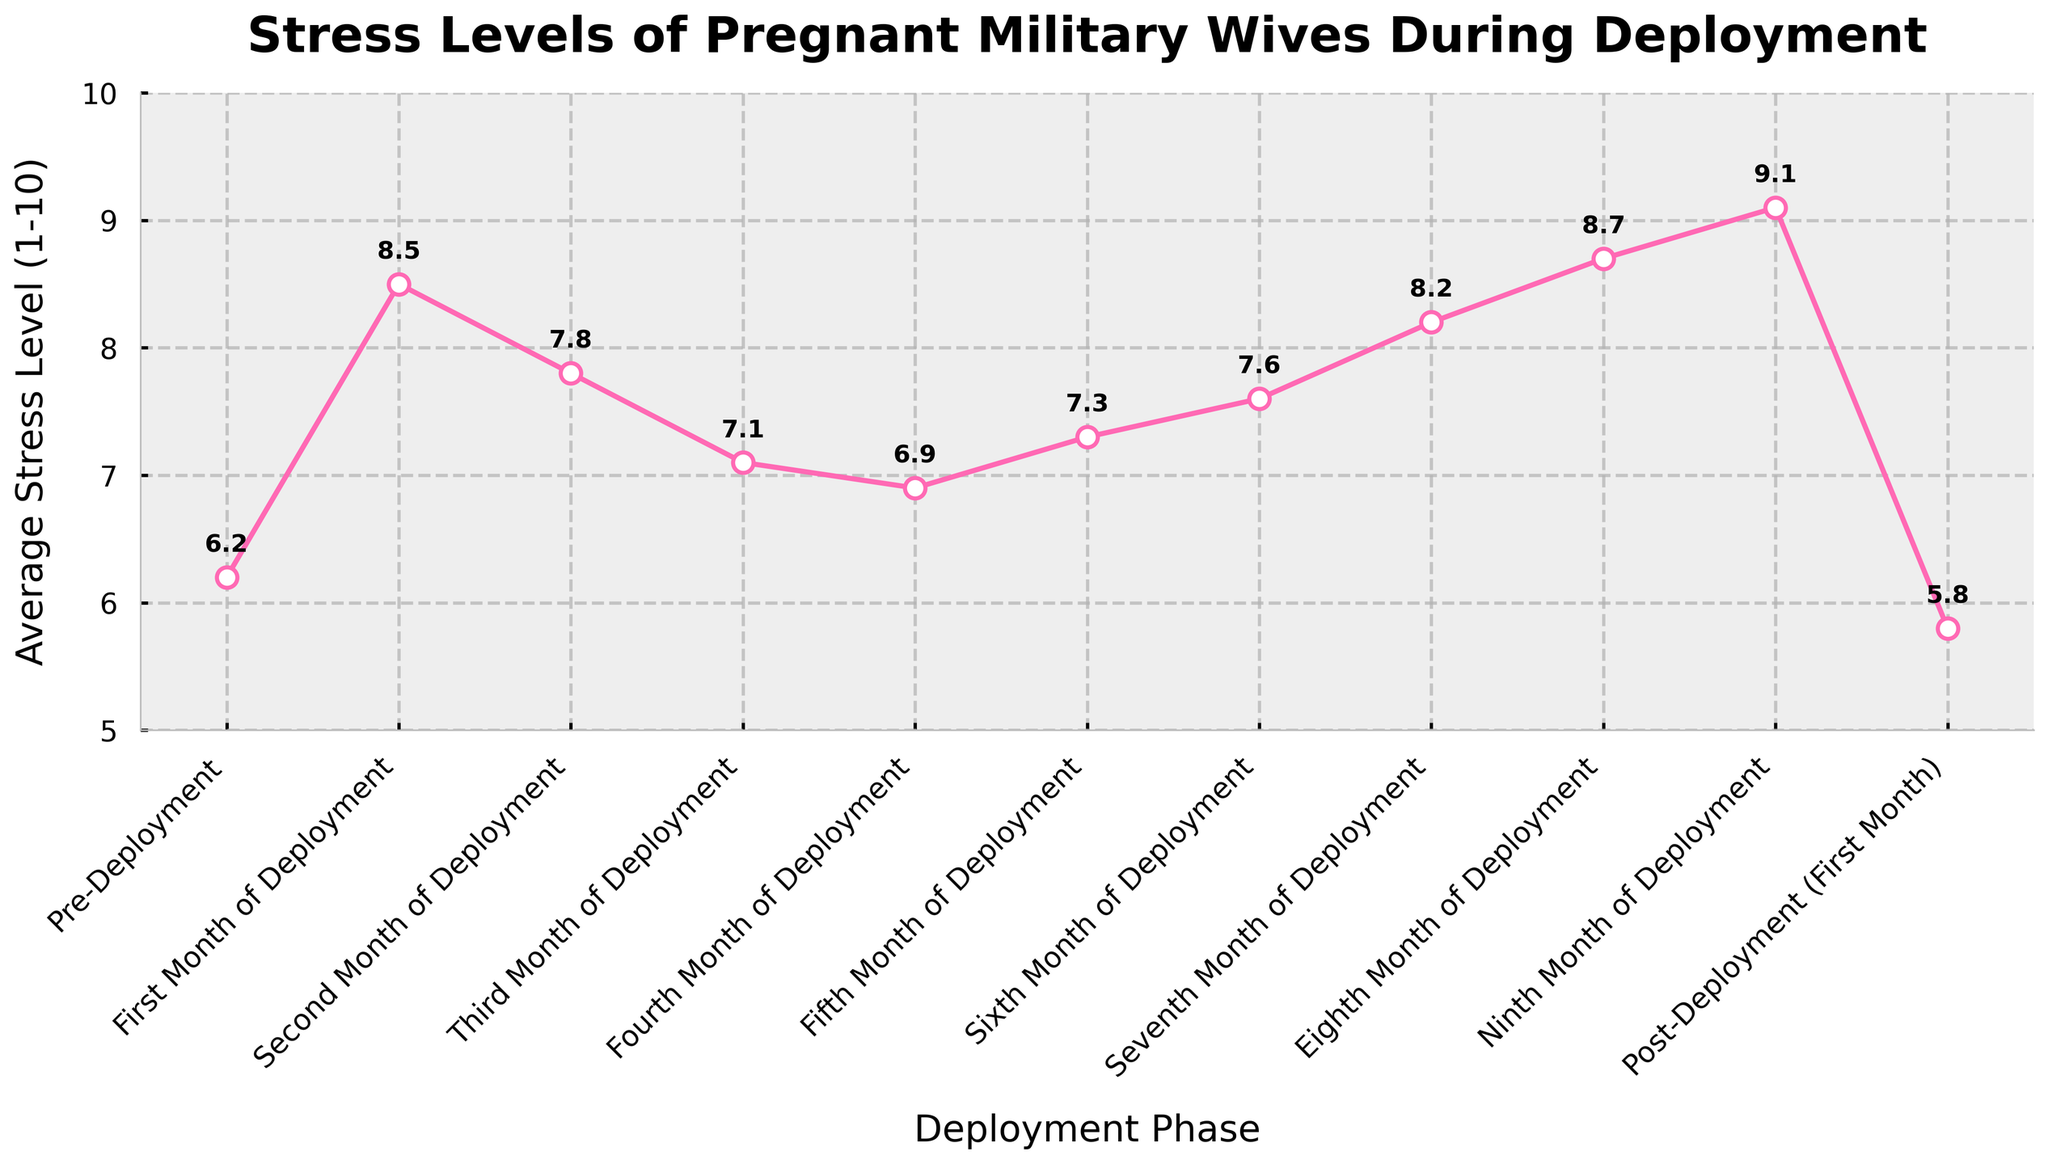What is the highest average stress level recorded during the deployment cycle? The highest average stress level can be found by looking at the peak of the line on the chart. The ninth month of deployment has the highest stress level at 9.1.
Answer: 9.1 Which deployment phase shows the lowest average stress level? The lowest average stress level is found by identifying the lowest point on the line chart. The post-deployment (first month) phase has the lowest stress level at 5.8.
Answer: Post-Deployment (First Month) What is the difference in average stress levels between the pre-deployment phase and the eighth month of deployment? The average stress level during the pre-deployment phase is 6.2. In the eighth month of deployment, it is 8.7. The difference is calculated as 8.7 - 6.2 = 2.5.
Answer: 2.5 How does the average stress level change from the sixth to the seventh month of deployment? The average stress level increases from 7.6 in the sixth month to 8.2 in the seventh month. The change is calculated as 8.2 - 7.6 = 0.6.
Answer: Increase by 0.6 During which deployment phase do stress levels first appear to decrease? By referring to the line chart, the first decrease occurs between the first month of deployment (8.5) and the second month of deployment (7.8).
Answer: Second Month of Deployment What is the average stress level over the entire deployment cycle? Sum all the average stress levels: 6.2 + 8.5 + 7.8 + 7.1 + 6.9 + 7.3 + 7.6 + 8.2 + 8.7 + 9.1 + 5.8 = 83.2. There are 11 phases, so the average is 83.2 / 11 ≈ 7.56.
Answer: 7.56 Compare the stress levels between the third month and the ninth month of deployment. Which one is higher and by how much? The stress level in the third month is 7.1, and in the ninth month, it is 9.1. The ninth month is higher by 9.1 - 7.1 = 2.0.
Answer: Ninth month, higher by 2.0 Is there any phase where the stress level is equal to 7.3? Yes, the stress level during the fifth month of deployment is 7.3.
Answer: Fifth Month of Deployment Which deployment phases show an average stress level below 7? By looking at the chart, the pre-deployment phase (6.2), fourth month of deployment (6.9), and post-deployment (5.8) have stress levels below 7.
Answer: Pre-Deployment, Fourth Month, Post-Deployment 